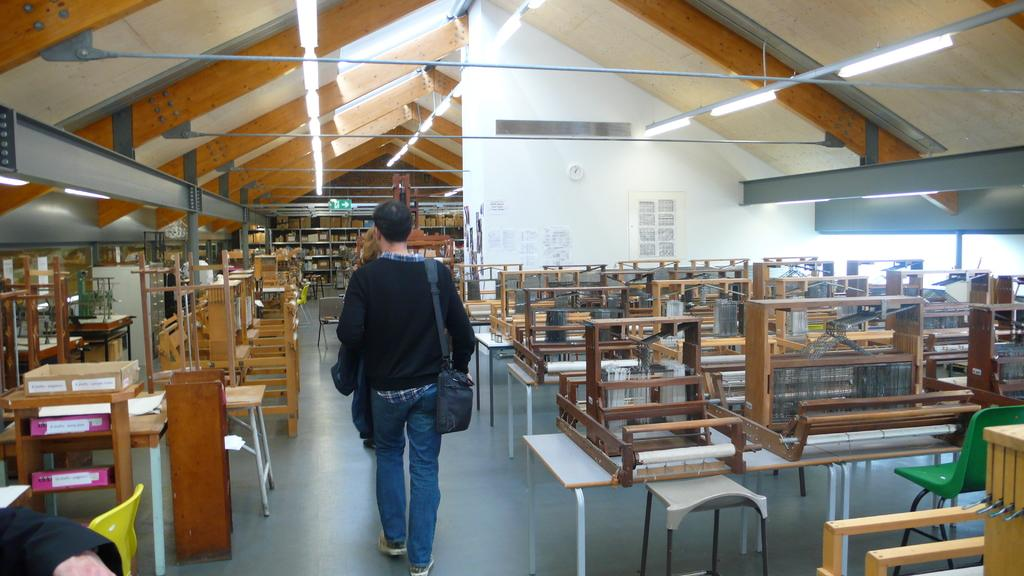Who is present in the image? There is a man in the image. What is the man doing in the image? The man is walking. Can you describe the room in the image? The room has wooden things, and the ceiling is made of wood. How many dolls are sitting on the jellyfish in the image? There are no dolls or jellyfish present in the image. What type of basket is hanging from the ceiling in the image? There is no basket present in the image. 